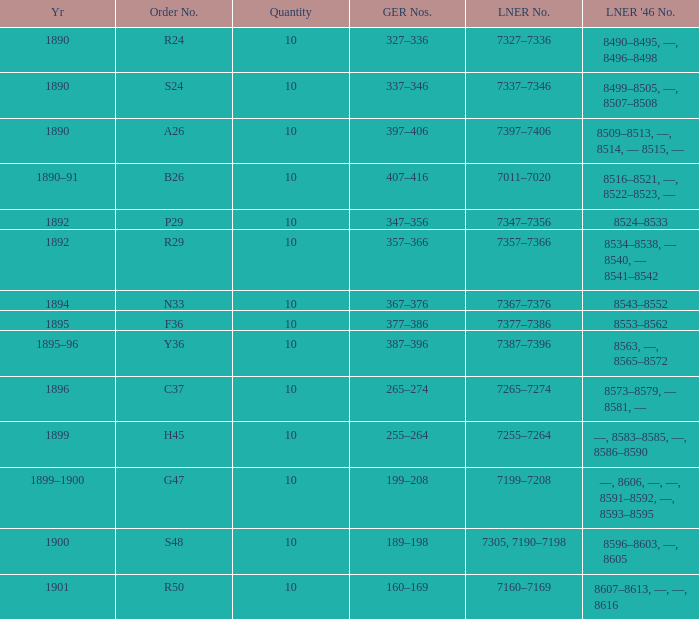What is order S24's LNER 1946 number? 8499–8505, —, 8507–8508. 